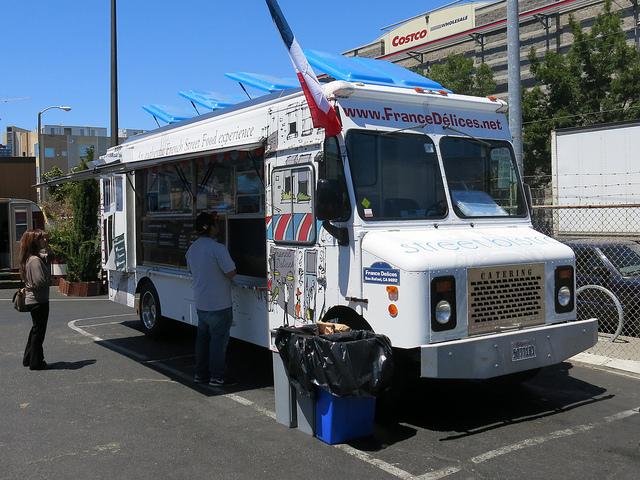What kind of truck is this?
Write a very short answer. Ice cream. How many trucks are there?
Short answer required. 1. What country is this picture likely in?
Answer briefly. France. What does this truck serve according to the Japanese lantern?
Write a very short answer. French food. What large retail company office building is this in front of?
Write a very short answer. Costco. What is the man wearing?
Keep it brief. Jeans. What is the best selling product?
Give a very brief answer. Ice cream. 